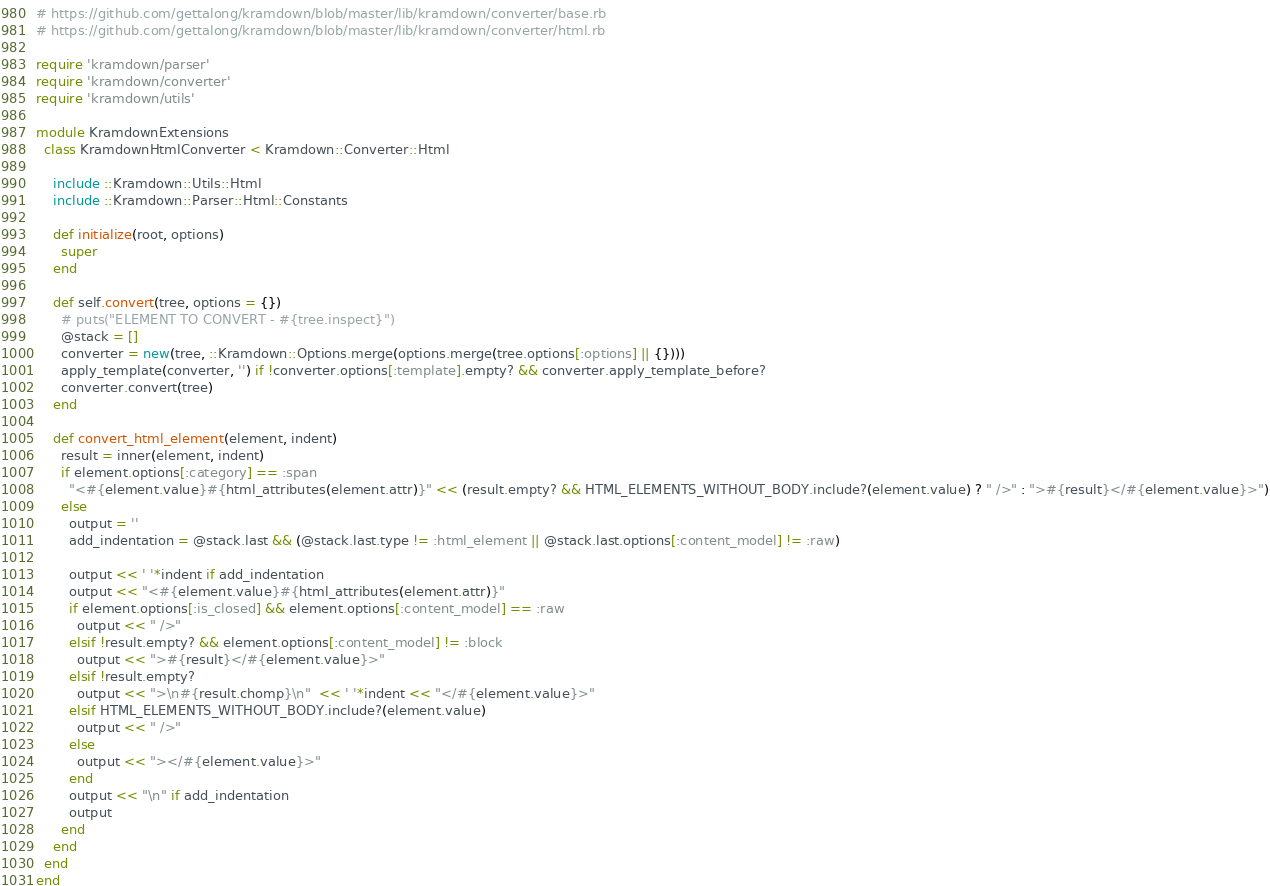<code> <loc_0><loc_0><loc_500><loc_500><_Ruby_># https://github.com/gettalong/kramdown/blob/master/lib/kramdown/converter/base.rb
# https://github.com/gettalong/kramdown/blob/master/lib/kramdown/converter/html.rb

require 'kramdown/parser'
require 'kramdown/converter'
require 'kramdown/utils'

module KramdownExtensions
  class KramdownHtmlConverter < Kramdown::Converter::Html

    include ::Kramdown::Utils::Html
    include ::Kramdown::Parser::Html::Constants

    def initialize(root, options)
      super
    end

    def self.convert(tree, options = {})
      # puts("ELEMENT TO CONVERT - #{tree.inspect}")
      @stack = []
      converter = new(tree, ::Kramdown::Options.merge(options.merge(tree.options[:options] || {})))
      apply_template(converter, '') if !converter.options[:template].empty? && converter.apply_template_before?
      converter.convert(tree)
    end

    def convert_html_element(element, indent)
      result = inner(element, indent)
      if element.options[:category] == :span
        "<#{element.value}#{html_attributes(element.attr)}" << (result.empty? && HTML_ELEMENTS_WITHOUT_BODY.include?(element.value) ? " />" : ">#{result}</#{element.value}>")
      else
        output = ''
        add_indentation = @stack.last && (@stack.last.type != :html_element || @stack.last.options[:content_model] != :raw)

        output << ' '*indent if add_indentation
        output << "<#{element.value}#{html_attributes(element.attr)}"
        if element.options[:is_closed] && element.options[:content_model] == :raw
          output << " />"
        elsif !result.empty? && element.options[:content_model] != :block
          output << ">#{result}</#{element.value}>"
        elsif !result.empty?
          output << ">\n#{result.chomp}\n"  << ' '*indent << "</#{element.value}>"
        elsif HTML_ELEMENTS_WITHOUT_BODY.include?(element.value)
          output << " />"
        else
          output << "></#{element.value}>"
        end
        output << "\n" if add_indentation
        output
      end
    end
  end
end
</code> 